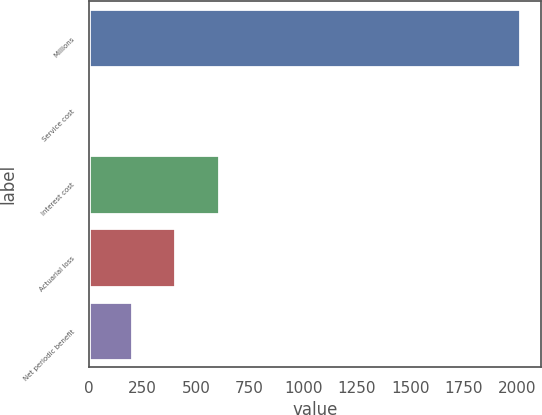<chart> <loc_0><loc_0><loc_500><loc_500><bar_chart><fcel>Millions<fcel>Service cost<fcel>Interest cost<fcel>Actuarial loss<fcel>Net periodic benefit<nl><fcel>2011<fcel>2<fcel>604.7<fcel>403.8<fcel>202.9<nl></chart> 